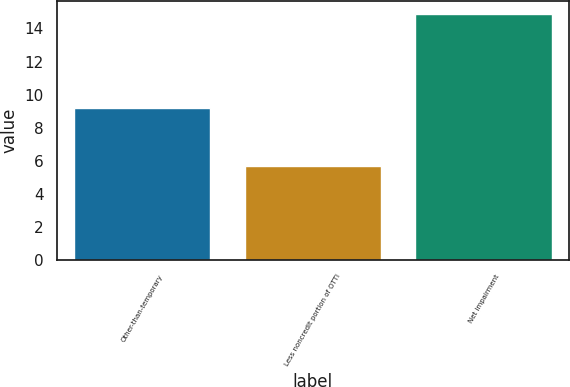<chart> <loc_0><loc_0><loc_500><loc_500><bar_chart><fcel>Other-than-temporary<fcel>Less noncredit portion of OTTI<fcel>Net impairment<nl><fcel>9.2<fcel>5.7<fcel>14.9<nl></chart> 